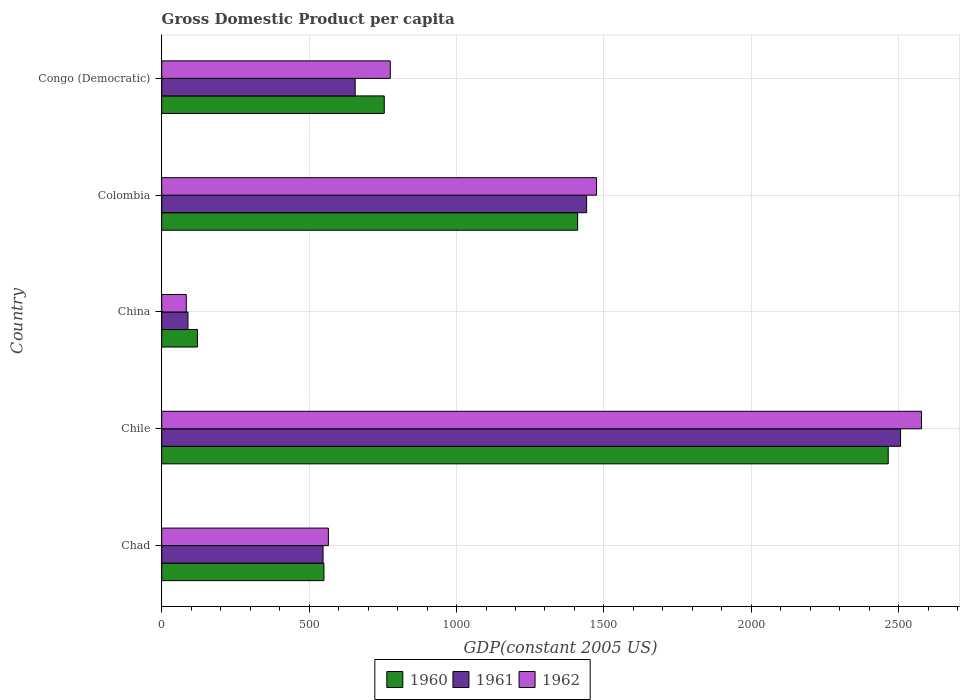How many different coloured bars are there?
Your response must be concise. 3. How many bars are there on the 2nd tick from the top?
Provide a short and direct response. 3. How many bars are there on the 4th tick from the bottom?
Provide a succinct answer. 3. What is the label of the 1st group of bars from the top?
Keep it short and to the point. Congo (Democratic). In how many cases, is the number of bars for a given country not equal to the number of legend labels?
Provide a succinct answer. 0. What is the GDP per capita in 1961 in Colombia?
Make the answer very short. 1441.14. Across all countries, what is the maximum GDP per capita in 1962?
Your response must be concise. 2577.05. Across all countries, what is the minimum GDP per capita in 1962?
Offer a very short reply. 83.33. In which country was the GDP per capita in 1960 maximum?
Your response must be concise. Chile. What is the total GDP per capita in 1960 in the graph?
Offer a very short reply. 5301.21. What is the difference between the GDP per capita in 1960 in Chad and that in China?
Offer a terse response. 429.05. What is the difference between the GDP per capita in 1962 in China and the GDP per capita in 1961 in Chile?
Your answer should be very brief. -2422.71. What is the average GDP per capita in 1962 per country?
Ensure brevity in your answer.  1095.19. What is the difference between the GDP per capita in 1960 and GDP per capita in 1962 in Colombia?
Make the answer very short. -64.19. In how many countries, is the GDP per capita in 1960 greater than 1800 US$?
Keep it short and to the point. 1. What is the ratio of the GDP per capita in 1960 in Chad to that in China?
Provide a short and direct response. 4.54. Is the difference between the GDP per capita in 1960 in China and Congo (Democratic) greater than the difference between the GDP per capita in 1962 in China and Congo (Democratic)?
Make the answer very short. Yes. What is the difference between the highest and the second highest GDP per capita in 1962?
Offer a very short reply. 1102.11. What is the difference between the highest and the lowest GDP per capita in 1960?
Your response must be concise. 2342.96. In how many countries, is the GDP per capita in 1960 greater than the average GDP per capita in 1960 taken over all countries?
Your answer should be very brief. 2. What does the 2nd bar from the top in Colombia represents?
Keep it short and to the point. 1961. Is it the case that in every country, the sum of the GDP per capita in 1961 and GDP per capita in 1960 is greater than the GDP per capita in 1962?
Keep it short and to the point. Yes. How many bars are there?
Ensure brevity in your answer.  15. Are all the bars in the graph horizontal?
Provide a succinct answer. Yes. How many countries are there in the graph?
Offer a terse response. 5. Are the values on the major ticks of X-axis written in scientific E-notation?
Offer a terse response. No. Does the graph contain any zero values?
Provide a short and direct response. No. Where does the legend appear in the graph?
Offer a terse response. Bottom center. How many legend labels are there?
Your answer should be very brief. 3. What is the title of the graph?
Offer a very short reply. Gross Domestic Product per capita. What is the label or title of the X-axis?
Your answer should be very brief. GDP(constant 2005 US). What is the label or title of the Y-axis?
Provide a succinct answer. Country. What is the GDP(constant 2005 US) of 1960 in Chad?
Your answer should be very brief. 550.24. What is the GDP(constant 2005 US) in 1961 in Chad?
Offer a terse response. 547.21. What is the GDP(constant 2005 US) of 1962 in Chad?
Keep it short and to the point. 565.29. What is the GDP(constant 2005 US) in 1960 in Chile?
Offer a terse response. 2464.15. What is the GDP(constant 2005 US) of 1961 in Chile?
Make the answer very short. 2506.04. What is the GDP(constant 2005 US) in 1962 in Chile?
Ensure brevity in your answer.  2577.05. What is the GDP(constant 2005 US) in 1960 in China?
Your answer should be very brief. 121.19. What is the GDP(constant 2005 US) in 1961 in China?
Keep it short and to the point. 89.01. What is the GDP(constant 2005 US) in 1962 in China?
Provide a short and direct response. 83.33. What is the GDP(constant 2005 US) in 1960 in Colombia?
Make the answer very short. 1410.75. What is the GDP(constant 2005 US) in 1961 in Colombia?
Offer a very short reply. 1441.14. What is the GDP(constant 2005 US) in 1962 in Colombia?
Ensure brevity in your answer.  1474.94. What is the GDP(constant 2005 US) of 1960 in Congo (Democratic)?
Give a very brief answer. 754.88. What is the GDP(constant 2005 US) of 1961 in Congo (Democratic)?
Give a very brief answer. 656.2. What is the GDP(constant 2005 US) of 1962 in Congo (Democratic)?
Keep it short and to the point. 775.32. Across all countries, what is the maximum GDP(constant 2005 US) in 1960?
Provide a succinct answer. 2464.15. Across all countries, what is the maximum GDP(constant 2005 US) of 1961?
Offer a very short reply. 2506.04. Across all countries, what is the maximum GDP(constant 2005 US) in 1962?
Give a very brief answer. 2577.05. Across all countries, what is the minimum GDP(constant 2005 US) of 1960?
Offer a terse response. 121.19. Across all countries, what is the minimum GDP(constant 2005 US) in 1961?
Keep it short and to the point. 89.01. Across all countries, what is the minimum GDP(constant 2005 US) of 1962?
Provide a succinct answer. 83.33. What is the total GDP(constant 2005 US) of 1960 in the graph?
Make the answer very short. 5301.21. What is the total GDP(constant 2005 US) in 1961 in the graph?
Offer a terse response. 5239.61. What is the total GDP(constant 2005 US) in 1962 in the graph?
Offer a very short reply. 5475.94. What is the difference between the GDP(constant 2005 US) in 1960 in Chad and that in Chile?
Give a very brief answer. -1913.91. What is the difference between the GDP(constant 2005 US) in 1961 in Chad and that in Chile?
Your answer should be very brief. -1958.84. What is the difference between the GDP(constant 2005 US) of 1962 in Chad and that in Chile?
Provide a succinct answer. -2011.76. What is the difference between the GDP(constant 2005 US) in 1960 in Chad and that in China?
Give a very brief answer. 429.05. What is the difference between the GDP(constant 2005 US) in 1961 in Chad and that in China?
Keep it short and to the point. 458.2. What is the difference between the GDP(constant 2005 US) in 1962 in Chad and that in China?
Provide a succinct answer. 481.95. What is the difference between the GDP(constant 2005 US) of 1960 in Chad and that in Colombia?
Provide a succinct answer. -860.51. What is the difference between the GDP(constant 2005 US) in 1961 in Chad and that in Colombia?
Offer a terse response. -893.93. What is the difference between the GDP(constant 2005 US) of 1962 in Chad and that in Colombia?
Provide a short and direct response. -909.66. What is the difference between the GDP(constant 2005 US) of 1960 in Chad and that in Congo (Democratic)?
Your answer should be compact. -204.64. What is the difference between the GDP(constant 2005 US) in 1961 in Chad and that in Congo (Democratic)?
Your answer should be compact. -108.99. What is the difference between the GDP(constant 2005 US) in 1962 in Chad and that in Congo (Democratic)?
Ensure brevity in your answer.  -210.03. What is the difference between the GDP(constant 2005 US) in 1960 in Chile and that in China?
Give a very brief answer. 2342.96. What is the difference between the GDP(constant 2005 US) in 1961 in Chile and that in China?
Your answer should be very brief. 2417.04. What is the difference between the GDP(constant 2005 US) in 1962 in Chile and that in China?
Offer a terse response. 2493.72. What is the difference between the GDP(constant 2005 US) of 1960 in Chile and that in Colombia?
Keep it short and to the point. 1053.4. What is the difference between the GDP(constant 2005 US) in 1961 in Chile and that in Colombia?
Provide a short and direct response. 1064.9. What is the difference between the GDP(constant 2005 US) in 1962 in Chile and that in Colombia?
Offer a terse response. 1102.11. What is the difference between the GDP(constant 2005 US) in 1960 in Chile and that in Congo (Democratic)?
Provide a succinct answer. 1709.27. What is the difference between the GDP(constant 2005 US) of 1961 in Chile and that in Congo (Democratic)?
Provide a succinct answer. 1849.84. What is the difference between the GDP(constant 2005 US) of 1962 in Chile and that in Congo (Democratic)?
Ensure brevity in your answer.  1801.74. What is the difference between the GDP(constant 2005 US) of 1960 in China and that in Colombia?
Your answer should be compact. -1289.56. What is the difference between the GDP(constant 2005 US) of 1961 in China and that in Colombia?
Provide a succinct answer. -1352.14. What is the difference between the GDP(constant 2005 US) in 1962 in China and that in Colombia?
Ensure brevity in your answer.  -1391.61. What is the difference between the GDP(constant 2005 US) in 1960 in China and that in Congo (Democratic)?
Give a very brief answer. -633.69. What is the difference between the GDP(constant 2005 US) of 1961 in China and that in Congo (Democratic)?
Your response must be concise. -567.2. What is the difference between the GDP(constant 2005 US) in 1962 in China and that in Congo (Democratic)?
Your response must be concise. -691.98. What is the difference between the GDP(constant 2005 US) in 1960 in Colombia and that in Congo (Democratic)?
Provide a short and direct response. 655.87. What is the difference between the GDP(constant 2005 US) in 1961 in Colombia and that in Congo (Democratic)?
Your response must be concise. 784.94. What is the difference between the GDP(constant 2005 US) of 1962 in Colombia and that in Congo (Democratic)?
Your answer should be compact. 699.63. What is the difference between the GDP(constant 2005 US) of 1960 in Chad and the GDP(constant 2005 US) of 1961 in Chile?
Your answer should be very brief. -1955.81. What is the difference between the GDP(constant 2005 US) in 1960 in Chad and the GDP(constant 2005 US) in 1962 in Chile?
Give a very brief answer. -2026.81. What is the difference between the GDP(constant 2005 US) in 1961 in Chad and the GDP(constant 2005 US) in 1962 in Chile?
Provide a succinct answer. -2029.84. What is the difference between the GDP(constant 2005 US) of 1960 in Chad and the GDP(constant 2005 US) of 1961 in China?
Offer a terse response. 461.23. What is the difference between the GDP(constant 2005 US) in 1960 in Chad and the GDP(constant 2005 US) in 1962 in China?
Your answer should be compact. 466.9. What is the difference between the GDP(constant 2005 US) in 1961 in Chad and the GDP(constant 2005 US) in 1962 in China?
Keep it short and to the point. 463.88. What is the difference between the GDP(constant 2005 US) of 1960 in Chad and the GDP(constant 2005 US) of 1961 in Colombia?
Keep it short and to the point. -890.9. What is the difference between the GDP(constant 2005 US) of 1960 in Chad and the GDP(constant 2005 US) of 1962 in Colombia?
Your response must be concise. -924.71. What is the difference between the GDP(constant 2005 US) in 1961 in Chad and the GDP(constant 2005 US) in 1962 in Colombia?
Your answer should be very brief. -927.74. What is the difference between the GDP(constant 2005 US) of 1960 in Chad and the GDP(constant 2005 US) of 1961 in Congo (Democratic)?
Offer a terse response. -105.96. What is the difference between the GDP(constant 2005 US) in 1960 in Chad and the GDP(constant 2005 US) in 1962 in Congo (Democratic)?
Offer a terse response. -225.08. What is the difference between the GDP(constant 2005 US) in 1961 in Chad and the GDP(constant 2005 US) in 1962 in Congo (Democratic)?
Your answer should be very brief. -228.11. What is the difference between the GDP(constant 2005 US) of 1960 in Chile and the GDP(constant 2005 US) of 1961 in China?
Offer a terse response. 2375.15. What is the difference between the GDP(constant 2005 US) of 1960 in Chile and the GDP(constant 2005 US) of 1962 in China?
Your answer should be very brief. 2380.82. What is the difference between the GDP(constant 2005 US) of 1961 in Chile and the GDP(constant 2005 US) of 1962 in China?
Keep it short and to the point. 2422.71. What is the difference between the GDP(constant 2005 US) of 1960 in Chile and the GDP(constant 2005 US) of 1961 in Colombia?
Your response must be concise. 1023.01. What is the difference between the GDP(constant 2005 US) in 1960 in Chile and the GDP(constant 2005 US) in 1962 in Colombia?
Keep it short and to the point. 989.21. What is the difference between the GDP(constant 2005 US) of 1961 in Chile and the GDP(constant 2005 US) of 1962 in Colombia?
Offer a terse response. 1031.1. What is the difference between the GDP(constant 2005 US) of 1960 in Chile and the GDP(constant 2005 US) of 1961 in Congo (Democratic)?
Offer a very short reply. 1807.95. What is the difference between the GDP(constant 2005 US) of 1960 in Chile and the GDP(constant 2005 US) of 1962 in Congo (Democratic)?
Give a very brief answer. 1688.83. What is the difference between the GDP(constant 2005 US) of 1961 in Chile and the GDP(constant 2005 US) of 1962 in Congo (Democratic)?
Provide a succinct answer. 1730.73. What is the difference between the GDP(constant 2005 US) in 1960 in China and the GDP(constant 2005 US) in 1961 in Colombia?
Give a very brief answer. -1319.95. What is the difference between the GDP(constant 2005 US) of 1960 in China and the GDP(constant 2005 US) of 1962 in Colombia?
Give a very brief answer. -1353.75. What is the difference between the GDP(constant 2005 US) of 1961 in China and the GDP(constant 2005 US) of 1962 in Colombia?
Your answer should be very brief. -1385.94. What is the difference between the GDP(constant 2005 US) of 1960 in China and the GDP(constant 2005 US) of 1961 in Congo (Democratic)?
Your response must be concise. -535.01. What is the difference between the GDP(constant 2005 US) in 1960 in China and the GDP(constant 2005 US) in 1962 in Congo (Democratic)?
Ensure brevity in your answer.  -654.13. What is the difference between the GDP(constant 2005 US) in 1961 in China and the GDP(constant 2005 US) in 1962 in Congo (Democratic)?
Keep it short and to the point. -686.31. What is the difference between the GDP(constant 2005 US) in 1960 in Colombia and the GDP(constant 2005 US) in 1961 in Congo (Democratic)?
Ensure brevity in your answer.  754.55. What is the difference between the GDP(constant 2005 US) in 1960 in Colombia and the GDP(constant 2005 US) in 1962 in Congo (Democratic)?
Give a very brief answer. 635.43. What is the difference between the GDP(constant 2005 US) of 1961 in Colombia and the GDP(constant 2005 US) of 1962 in Congo (Democratic)?
Offer a very short reply. 665.82. What is the average GDP(constant 2005 US) in 1960 per country?
Make the answer very short. 1060.24. What is the average GDP(constant 2005 US) in 1961 per country?
Your answer should be very brief. 1047.92. What is the average GDP(constant 2005 US) of 1962 per country?
Offer a terse response. 1095.19. What is the difference between the GDP(constant 2005 US) in 1960 and GDP(constant 2005 US) in 1961 in Chad?
Your response must be concise. 3.03. What is the difference between the GDP(constant 2005 US) in 1960 and GDP(constant 2005 US) in 1962 in Chad?
Your answer should be compact. -15.05. What is the difference between the GDP(constant 2005 US) of 1961 and GDP(constant 2005 US) of 1962 in Chad?
Offer a very short reply. -18.08. What is the difference between the GDP(constant 2005 US) in 1960 and GDP(constant 2005 US) in 1961 in Chile?
Offer a very short reply. -41.89. What is the difference between the GDP(constant 2005 US) in 1960 and GDP(constant 2005 US) in 1962 in Chile?
Provide a succinct answer. -112.9. What is the difference between the GDP(constant 2005 US) in 1961 and GDP(constant 2005 US) in 1962 in Chile?
Your answer should be very brief. -71.01. What is the difference between the GDP(constant 2005 US) of 1960 and GDP(constant 2005 US) of 1961 in China?
Provide a succinct answer. 32.19. What is the difference between the GDP(constant 2005 US) of 1960 and GDP(constant 2005 US) of 1962 in China?
Keep it short and to the point. 37.86. What is the difference between the GDP(constant 2005 US) in 1961 and GDP(constant 2005 US) in 1962 in China?
Your response must be concise. 5.67. What is the difference between the GDP(constant 2005 US) of 1960 and GDP(constant 2005 US) of 1961 in Colombia?
Offer a terse response. -30.39. What is the difference between the GDP(constant 2005 US) of 1960 and GDP(constant 2005 US) of 1962 in Colombia?
Make the answer very short. -64.19. What is the difference between the GDP(constant 2005 US) of 1961 and GDP(constant 2005 US) of 1962 in Colombia?
Give a very brief answer. -33.8. What is the difference between the GDP(constant 2005 US) in 1960 and GDP(constant 2005 US) in 1961 in Congo (Democratic)?
Keep it short and to the point. 98.68. What is the difference between the GDP(constant 2005 US) of 1960 and GDP(constant 2005 US) of 1962 in Congo (Democratic)?
Give a very brief answer. -20.44. What is the difference between the GDP(constant 2005 US) of 1961 and GDP(constant 2005 US) of 1962 in Congo (Democratic)?
Your answer should be very brief. -119.11. What is the ratio of the GDP(constant 2005 US) in 1960 in Chad to that in Chile?
Offer a terse response. 0.22. What is the ratio of the GDP(constant 2005 US) of 1961 in Chad to that in Chile?
Your answer should be very brief. 0.22. What is the ratio of the GDP(constant 2005 US) in 1962 in Chad to that in Chile?
Your answer should be very brief. 0.22. What is the ratio of the GDP(constant 2005 US) of 1960 in Chad to that in China?
Offer a terse response. 4.54. What is the ratio of the GDP(constant 2005 US) of 1961 in Chad to that in China?
Give a very brief answer. 6.15. What is the ratio of the GDP(constant 2005 US) of 1962 in Chad to that in China?
Provide a succinct answer. 6.78. What is the ratio of the GDP(constant 2005 US) of 1960 in Chad to that in Colombia?
Ensure brevity in your answer.  0.39. What is the ratio of the GDP(constant 2005 US) of 1961 in Chad to that in Colombia?
Keep it short and to the point. 0.38. What is the ratio of the GDP(constant 2005 US) of 1962 in Chad to that in Colombia?
Offer a terse response. 0.38. What is the ratio of the GDP(constant 2005 US) in 1960 in Chad to that in Congo (Democratic)?
Give a very brief answer. 0.73. What is the ratio of the GDP(constant 2005 US) in 1961 in Chad to that in Congo (Democratic)?
Offer a very short reply. 0.83. What is the ratio of the GDP(constant 2005 US) of 1962 in Chad to that in Congo (Democratic)?
Your answer should be compact. 0.73. What is the ratio of the GDP(constant 2005 US) in 1960 in Chile to that in China?
Your answer should be compact. 20.33. What is the ratio of the GDP(constant 2005 US) of 1961 in Chile to that in China?
Offer a terse response. 28.16. What is the ratio of the GDP(constant 2005 US) of 1962 in Chile to that in China?
Provide a succinct answer. 30.92. What is the ratio of the GDP(constant 2005 US) of 1960 in Chile to that in Colombia?
Your response must be concise. 1.75. What is the ratio of the GDP(constant 2005 US) of 1961 in Chile to that in Colombia?
Make the answer very short. 1.74. What is the ratio of the GDP(constant 2005 US) of 1962 in Chile to that in Colombia?
Your response must be concise. 1.75. What is the ratio of the GDP(constant 2005 US) of 1960 in Chile to that in Congo (Democratic)?
Your response must be concise. 3.26. What is the ratio of the GDP(constant 2005 US) of 1961 in Chile to that in Congo (Democratic)?
Provide a succinct answer. 3.82. What is the ratio of the GDP(constant 2005 US) in 1962 in Chile to that in Congo (Democratic)?
Make the answer very short. 3.32. What is the ratio of the GDP(constant 2005 US) in 1960 in China to that in Colombia?
Your answer should be compact. 0.09. What is the ratio of the GDP(constant 2005 US) in 1961 in China to that in Colombia?
Offer a very short reply. 0.06. What is the ratio of the GDP(constant 2005 US) of 1962 in China to that in Colombia?
Your answer should be compact. 0.06. What is the ratio of the GDP(constant 2005 US) in 1960 in China to that in Congo (Democratic)?
Your answer should be very brief. 0.16. What is the ratio of the GDP(constant 2005 US) in 1961 in China to that in Congo (Democratic)?
Keep it short and to the point. 0.14. What is the ratio of the GDP(constant 2005 US) of 1962 in China to that in Congo (Democratic)?
Your answer should be very brief. 0.11. What is the ratio of the GDP(constant 2005 US) of 1960 in Colombia to that in Congo (Democratic)?
Your answer should be compact. 1.87. What is the ratio of the GDP(constant 2005 US) of 1961 in Colombia to that in Congo (Democratic)?
Offer a terse response. 2.2. What is the ratio of the GDP(constant 2005 US) in 1962 in Colombia to that in Congo (Democratic)?
Your response must be concise. 1.9. What is the difference between the highest and the second highest GDP(constant 2005 US) in 1960?
Your response must be concise. 1053.4. What is the difference between the highest and the second highest GDP(constant 2005 US) of 1961?
Keep it short and to the point. 1064.9. What is the difference between the highest and the second highest GDP(constant 2005 US) in 1962?
Your answer should be compact. 1102.11. What is the difference between the highest and the lowest GDP(constant 2005 US) in 1960?
Your response must be concise. 2342.96. What is the difference between the highest and the lowest GDP(constant 2005 US) of 1961?
Provide a succinct answer. 2417.04. What is the difference between the highest and the lowest GDP(constant 2005 US) in 1962?
Provide a succinct answer. 2493.72. 